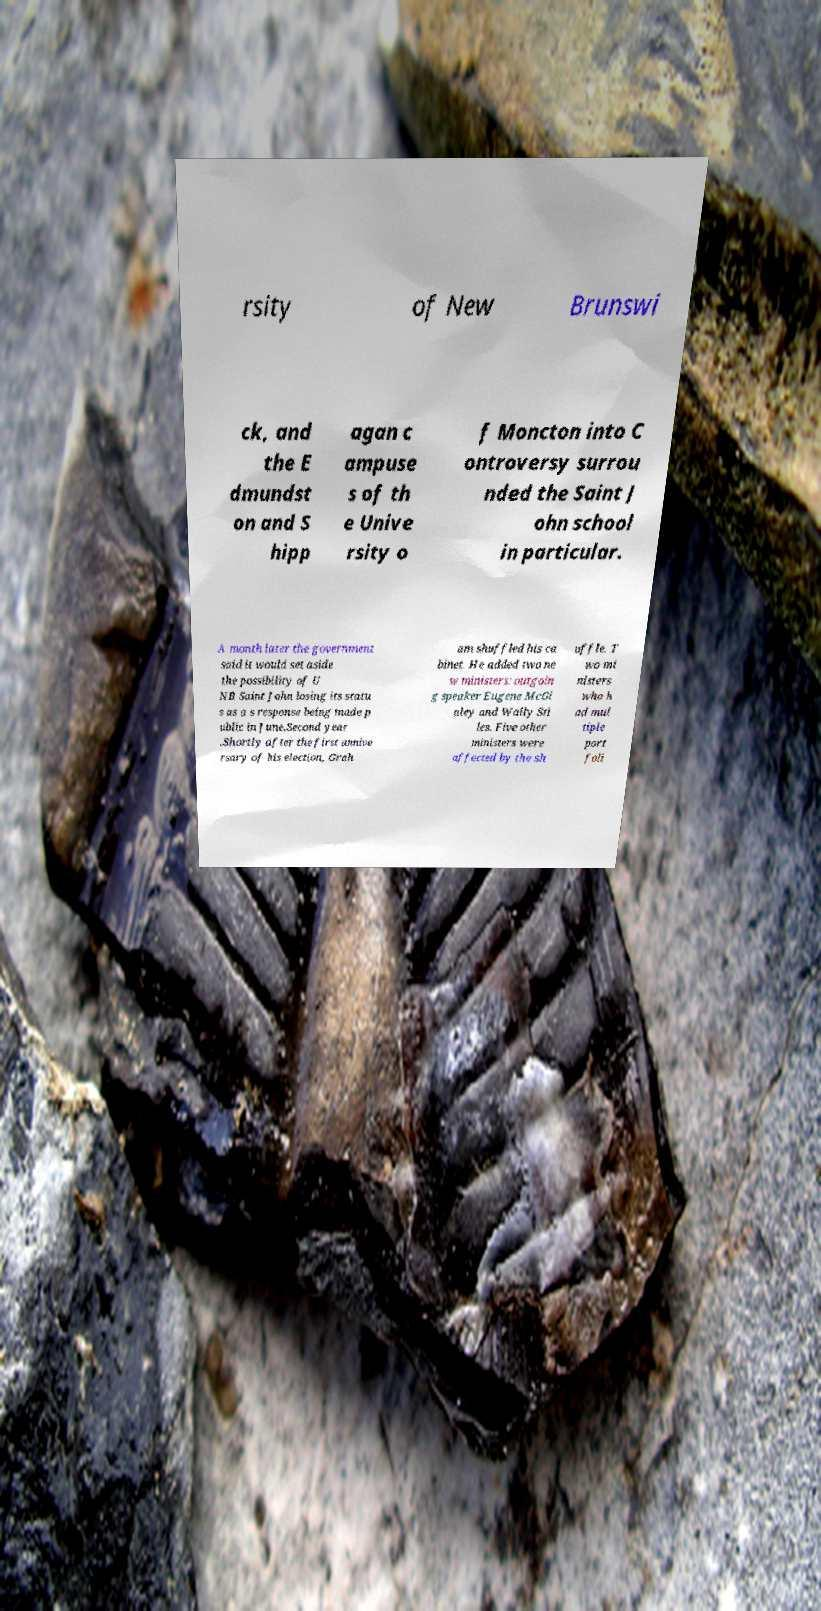Could you assist in decoding the text presented in this image and type it out clearly? rsity of New Brunswi ck, and the E dmundst on and S hipp agan c ampuse s of th e Unive rsity o f Moncton into C ontroversy surrou nded the Saint J ohn school in particular. A month later the government said it would set aside the possibility of U NB Saint John losing its statu s as a s response being made p ublic in June.Second year .Shortly after the first annive rsary of his election, Grah am shuffled his ca binet. He added two ne w ministers: outgoin g speaker Eugene McGi nley and Wally Sti les. Five other ministers were affected by the sh uffle. T wo mi nisters who h ad mul tiple port foli 